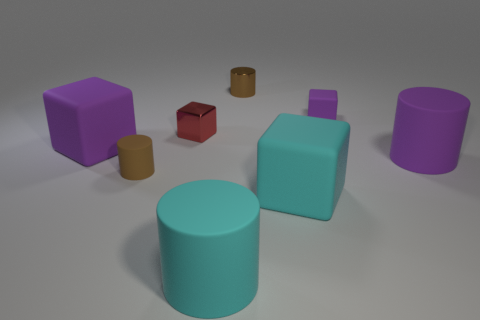What is the material of the cyan object that is the same shape as the tiny purple rubber thing?
Make the answer very short. Rubber. Does the purple cube that is left of the shiny cylinder have the same size as the small red object?
Ensure brevity in your answer.  No. How many matte things are tiny red cubes or small purple things?
Make the answer very short. 1. The cube that is in front of the tiny red block and right of the brown rubber object is made of what material?
Offer a terse response. Rubber. Is the big purple block made of the same material as the large cyan cylinder?
Your response must be concise. Yes. There is a object that is on the left side of the tiny purple matte block and behind the small red cube; what is its size?
Make the answer very short. Small. The small red shiny thing has what shape?
Your answer should be compact. Cube. What number of objects are either brown metallic objects or matte objects that are behind the red shiny cube?
Offer a terse response. 2. Does the large rubber cylinder left of the cyan rubber block have the same color as the metal cylinder?
Provide a short and direct response. No. The rubber object that is in front of the small purple block and right of the cyan rubber block is what color?
Provide a short and direct response. Purple. 